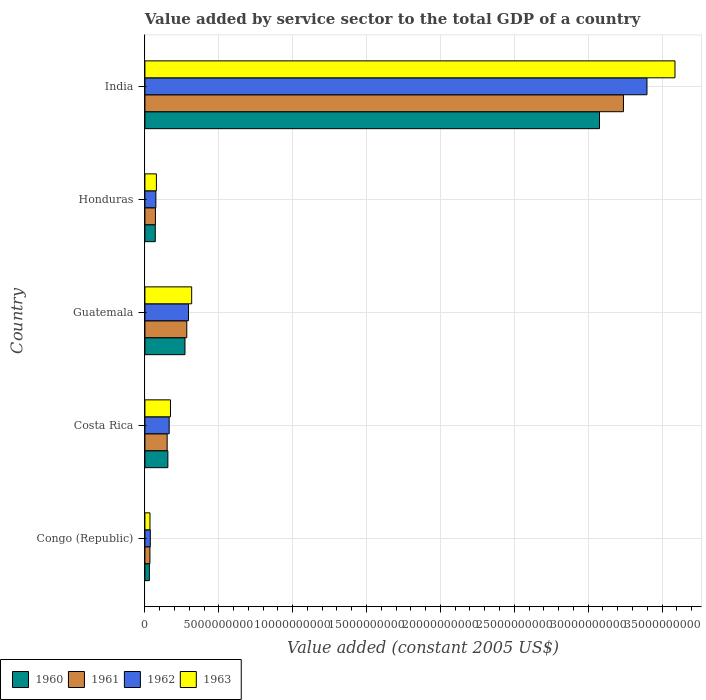Are the number of bars per tick equal to the number of legend labels?
Provide a short and direct response. Yes. How many bars are there on the 5th tick from the top?
Your answer should be compact. 4. How many bars are there on the 5th tick from the bottom?
Keep it short and to the point. 4. What is the label of the 3rd group of bars from the top?
Make the answer very short. Guatemala. What is the value added by service sector in 1960 in Guatemala?
Offer a very short reply. 2.71e+09. Across all countries, what is the maximum value added by service sector in 1962?
Make the answer very short. 3.40e+1. Across all countries, what is the minimum value added by service sector in 1961?
Your answer should be very brief. 3.39e+08. In which country was the value added by service sector in 1962 maximum?
Your response must be concise. India. In which country was the value added by service sector in 1962 minimum?
Your answer should be compact. Congo (Republic). What is the total value added by service sector in 1960 in the graph?
Provide a short and direct response. 3.60e+1. What is the difference between the value added by service sector in 1962 in Guatemala and that in India?
Provide a short and direct response. -3.10e+1. What is the difference between the value added by service sector in 1963 in India and the value added by service sector in 1961 in Congo (Republic)?
Provide a short and direct response. 3.55e+1. What is the average value added by service sector in 1963 per country?
Ensure brevity in your answer.  8.38e+09. What is the difference between the value added by service sector in 1961 and value added by service sector in 1960 in India?
Your response must be concise. 1.62e+09. In how many countries, is the value added by service sector in 1963 greater than 12000000000 US$?
Your response must be concise. 1. What is the ratio of the value added by service sector in 1963 in Congo (Republic) to that in Guatemala?
Offer a terse response. 0.11. Is the difference between the value added by service sector in 1961 in Costa Rica and India greater than the difference between the value added by service sector in 1960 in Costa Rica and India?
Your answer should be very brief. No. What is the difference between the highest and the second highest value added by service sector in 1963?
Provide a short and direct response. 3.27e+1. What is the difference between the highest and the lowest value added by service sector in 1962?
Provide a succinct answer. 3.36e+1. Is the sum of the value added by service sector in 1962 in Costa Rica and Guatemala greater than the maximum value added by service sector in 1963 across all countries?
Keep it short and to the point. No. What does the 2nd bar from the top in Costa Rica represents?
Keep it short and to the point. 1962. Is it the case that in every country, the sum of the value added by service sector in 1963 and value added by service sector in 1961 is greater than the value added by service sector in 1960?
Offer a very short reply. Yes. How many bars are there?
Offer a terse response. 20. Are all the bars in the graph horizontal?
Your answer should be very brief. Yes. Are the values on the major ticks of X-axis written in scientific E-notation?
Give a very brief answer. No. Where does the legend appear in the graph?
Your answer should be compact. Bottom left. How many legend labels are there?
Your response must be concise. 4. How are the legend labels stacked?
Make the answer very short. Horizontal. What is the title of the graph?
Give a very brief answer. Value added by service sector to the total GDP of a country. Does "1988" appear as one of the legend labels in the graph?
Your response must be concise. No. What is the label or title of the X-axis?
Keep it short and to the point. Value added (constant 2005 US$). What is the label or title of the Y-axis?
Your answer should be compact. Country. What is the Value added (constant 2005 US$) of 1960 in Congo (Republic)?
Offer a terse response. 3.02e+08. What is the Value added (constant 2005 US$) of 1961 in Congo (Republic)?
Offer a terse response. 3.39e+08. What is the Value added (constant 2005 US$) of 1962 in Congo (Republic)?
Give a very brief answer. 3.64e+08. What is the Value added (constant 2005 US$) of 1963 in Congo (Republic)?
Provide a short and direct response. 3.42e+08. What is the Value added (constant 2005 US$) of 1960 in Costa Rica?
Make the answer very short. 1.55e+09. What is the Value added (constant 2005 US$) of 1961 in Costa Rica?
Offer a terse response. 1.51e+09. What is the Value added (constant 2005 US$) in 1962 in Costa Rica?
Your response must be concise. 1.64e+09. What is the Value added (constant 2005 US$) of 1963 in Costa Rica?
Keep it short and to the point. 1.73e+09. What is the Value added (constant 2005 US$) of 1960 in Guatemala?
Provide a short and direct response. 2.71e+09. What is the Value added (constant 2005 US$) of 1961 in Guatemala?
Keep it short and to the point. 2.83e+09. What is the Value added (constant 2005 US$) of 1962 in Guatemala?
Ensure brevity in your answer.  2.95e+09. What is the Value added (constant 2005 US$) of 1963 in Guatemala?
Your answer should be very brief. 3.16e+09. What is the Value added (constant 2005 US$) in 1960 in Honduras?
Give a very brief answer. 7.01e+08. What is the Value added (constant 2005 US$) in 1961 in Honduras?
Your answer should be compact. 7.12e+08. What is the Value added (constant 2005 US$) of 1962 in Honduras?
Provide a succinct answer. 7.41e+08. What is the Value added (constant 2005 US$) of 1963 in Honduras?
Your answer should be very brief. 7.78e+08. What is the Value added (constant 2005 US$) of 1960 in India?
Your answer should be very brief. 3.08e+1. What is the Value added (constant 2005 US$) of 1961 in India?
Keep it short and to the point. 3.24e+1. What is the Value added (constant 2005 US$) of 1962 in India?
Your response must be concise. 3.40e+1. What is the Value added (constant 2005 US$) of 1963 in India?
Make the answer very short. 3.59e+1. Across all countries, what is the maximum Value added (constant 2005 US$) in 1960?
Your response must be concise. 3.08e+1. Across all countries, what is the maximum Value added (constant 2005 US$) in 1961?
Make the answer very short. 3.24e+1. Across all countries, what is the maximum Value added (constant 2005 US$) of 1962?
Offer a very short reply. 3.40e+1. Across all countries, what is the maximum Value added (constant 2005 US$) in 1963?
Ensure brevity in your answer.  3.59e+1. Across all countries, what is the minimum Value added (constant 2005 US$) of 1960?
Provide a succinct answer. 3.02e+08. Across all countries, what is the minimum Value added (constant 2005 US$) of 1961?
Offer a terse response. 3.39e+08. Across all countries, what is the minimum Value added (constant 2005 US$) in 1962?
Your response must be concise. 3.64e+08. Across all countries, what is the minimum Value added (constant 2005 US$) in 1963?
Provide a short and direct response. 3.42e+08. What is the total Value added (constant 2005 US$) in 1960 in the graph?
Give a very brief answer. 3.60e+1. What is the total Value added (constant 2005 US$) of 1961 in the graph?
Offer a very short reply. 3.78e+1. What is the total Value added (constant 2005 US$) in 1962 in the graph?
Offer a terse response. 3.97e+1. What is the total Value added (constant 2005 US$) in 1963 in the graph?
Give a very brief answer. 4.19e+1. What is the difference between the Value added (constant 2005 US$) in 1960 in Congo (Republic) and that in Costa Rica?
Give a very brief answer. -1.25e+09. What is the difference between the Value added (constant 2005 US$) of 1961 in Congo (Republic) and that in Costa Rica?
Ensure brevity in your answer.  -1.17e+09. What is the difference between the Value added (constant 2005 US$) of 1962 in Congo (Republic) and that in Costa Rica?
Provide a short and direct response. -1.28e+09. What is the difference between the Value added (constant 2005 US$) in 1963 in Congo (Republic) and that in Costa Rica?
Provide a short and direct response. -1.39e+09. What is the difference between the Value added (constant 2005 US$) of 1960 in Congo (Republic) and that in Guatemala?
Your answer should be very brief. -2.41e+09. What is the difference between the Value added (constant 2005 US$) in 1961 in Congo (Republic) and that in Guatemala?
Offer a terse response. -2.49e+09. What is the difference between the Value added (constant 2005 US$) of 1962 in Congo (Republic) and that in Guatemala?
Provide a succinct answer. -2.58e+09. What is the difference between the Value added (constant 2005 US$) in 1963 in Congo (Republic) and that in Guatemala?
Your answer should be very brief. -2.82e+09. What is the difference between the Value added (constant 2005 US$) of 1960 in Congo (Republic) and that in Honduras?
Offer a terse response. -4.00e+08. What is the difference between the Value added (constant 2005 US$) of 1961 in Congo (Republic) and that in Honduras?
Offer a terse response. -3.73e+08. What is the difference between the Value added (constant 2005 US$) of 1962 in Congo (Republic) and that in Honduras?
Offer a terse response. -3.77e+08. What is the difference between the Value added (constant 2005 US$) of 1963 in Congo (Republic) and that in Honduras?
Your answer should be very brief. -4.36e+08. What is the difference between the Value added (constant 2005 US$) in 1960 in Congo (Republic) and that in India?
Provide a succinct answer. -3.05e+1. What is the difference between the Value added (constant 2005 US$) of 1961 in Congo (Republic) and that in India?
Offer a terse response. -3.21e+1. What is the difference between the Value added (constant 2005 US$) of 1962 in Congo (Republic) and that in India?
Provide a succinct answer. -3.36e+1. What is the difference between the Value added (constant 2005 US$) of 1963 in Congo (Republic) and that in India?
Keep it short and to the point. -3.55e+1. What is the difference between the Value added (constant 2005 US$) of 1960 in Costa Rica and that in Guatemala?
Your answer should be compact. -1.16e+09. What is the difference between the Value added (constant 2005 US$) of 1961 in Costa Rica and that in Guatemala?
Offer a terse response. -1.33e+09. What is the difference between the Value added (constant 2005 US$) in 1962 in Costa Rica and that in Guatemala?
Give a very brief answer. -1.31e+09. What is the difference between the Value added (constant 2005 US$) in 1963 in Costa Rica and that in Guatemala?
Offer a terse response. -1.43e+09. What is the difference between the Value added (constant 2005 US$) of 1960 in Costa Rica and that in Honduras?
Offer a terse response. 8.51e+08. What is the difference between the Value added (constant 2005 US$) in 1961 in Costa Rica and that in Honduras?
Provide a succinct answer. 7.94e+08. What is the difference between the Value added (constant 2005 US$) of 1962 in Costa Rica and that in Honduras?
Offer a terse response. 9.01e+08. What is the difference between the Value added (constant 2005 US$) in 1963 in Costa Rica and that in Honduras?
Offer a very short reply. 9.53e+08. What is the difference between the Value added (constant 2005 US$) in 1960 in Costa Rica and that in India?
Provide a short and direct response. -2.92e+1. What is the difference between the Value added (constant 2005 US$) of 1961 in Costa Rica and that in India?
Provide a short and direct response. -3.09e+1. What is the difference between the Value added (constant 2005 US$) in 1962 in Costa Rica and that in India?
Give a very brief answer. -3.23e+1. What is the difference between the Value added (constant 2005 US$) in 1963 in Costa Rica and that in India?
Provide a short and direct response. -3.41e+1. What is the difference between the Value added (constant 2005 US$) in 1960 in Guatemala and that in Honduras?
Your answer should be very brief. 2.01e+09. What is the difference between the Value added (constant 2005 US$) of 1961 in Guatemala and that in Honduras?
Your answer should be compact. 2.12e+09. What is the difference between the Value added (constant 2005 US$) of 1962 in Guatemala and that in Honduras?
Keep it short and to the point. 2.21e+09. What is the difference between the Value added (constant 2005 US$) in 1963 in Guatemala and that in Honduras?
Keep it short and to the point. 2.39e+09. What is the difference between the Value added (constant 2005 US$) of 1960 in Guatemala and that in India?
Provide a succinct answer. -2.81e+1. What is the difference between the Value added (constant 2005 US$) of 1961 in Guatemala and that in India?
Keep it short and to the point. -2.96e+1. What is the difference between the Value added (constant 2005 US$) in 1962 in Guatemala and that in India?
Offer a terse response. -3.10e+1. What is the difference between the Value added (constant 2005 US$) of 1963 in Guatemala and that in India?
Your response must be concise. -3.27e+1. What is the difference between the Value added (constant 2005 US$) of 1960 in Honduras and that in India?
Ensure brevity in your answer.  -3.01e+1. What is the difference between the Value added (constant 2005 US$) of 1961 in Honduras and that in India?
Give a very brief answer. -3.17e+1. What is the difference between the Value added (constant 2005 US$) of 1962 in Honduras and that in India?
Ensure brevity in your answer.  -3.32e+1. What is the difference between the Value added (constant 2005 US$) of 1963 in Honduras and that in India?
Your answer should be very brief. -3.51e+1. What is the difference between the Value added (constant 2005 US$) in 1960 in Congo (Republic) and the Value added (constant 2005 US$) in 1961 in Costa Rica?
Provide a short and direct response. -1.20e+09. What is the difference between the Value added (constant 2005 US$) of 1960 in Congo (Republic) and the Value added (constant 2005 US$) of 1962 in Costa Rica?
Offer a terse response. -1.34e+09. What is the difference between the Value added (constant 2005 US$) of 1960 in Congo (Republic) and the Value added (constant 2005 US$) of 1963 in Costa Rica?
Your response must be concise. -1.43e+09. What is the difference between the Value added (constant 2005 US$) in 1961 in Congo (Republic) and the Value added (constant 2005 US$) in 1962 in Costa Rica?
Provide a succinct answer. -1.30e+09. What is the difference between the Value added (constant 2005 US$) of 1961 in Congo (Republic) and the Value added (constant 2005 US$) of 1963 in Costa Rica?
Offer a terse response. -1.39e+09. What is the difference between the Value added (constant 2005 US$) in 1962 in Congo (Republic) and the Value added (constant 2005 US$) in 1963 in Costa Rica?
Provide a short and direct response. -1.37e+09. What is the difference between the Value added (constant 2005 US$) in 1960 in Congo (Republic) and the Value added (constant 2005 US$) in 1961 in Guatemala?
Your answer should be compact. -2.53e+09. What is the difference between the Value added (constant 2005 US$) in 1960 in Congo (Republic) and the Value added (constant 2005 US$) in 1962 in Guatemala?
Make the answer very short. -2.65e+09. What is the difference between the Value added (constant 2005 US$) of 1960 in Congo (Republic) and the Value added (constant 2005 US$) of 1963 in Guatemala?
Your response must be concise. -2.86e+09. What is the difference between the Value added (constant 2005 US$) of 1961 in Congo (Republic) and the Value added (constant 2005 US$) of 1962 in Guatemala?
Your answer should be compact. -2.61e+09. What is the difference between the Value added (constant 2005 US$) of 1961 in Congo (Republic) and the Value added (constant 2005 US$) of 1963 in Guatemala?
Your answer should be compact. -2.83e+09. What is the difference between the Value added (constant 2005 US$) of 1962 in Congo (Republic) and the Value added (constant 2005 US$) of 1963 in Guatemala?
Make the answer very short. -2.80e+09. What is the difference between the Value added (constant 2005 US$) in 1960 in Congo (Republic) and the Value added (constant 2005 US$) in 1961 in Honduras?
Give a very brief answer. -4.10e+08. What is the difference between the Value added (constant 2005 US$) in 1960 in Congo (Republic) and the Value added (constant 2005 US$) in 1962 in Honduras?
Your answer should be compact. -4.39e+08. What is the difference between the Value added (constant 2005 US$) in 1960 in Congo (Republic) and the Value added (constant 2005 US$) in 1963 in Honduras?
Ensure brevity in your answer.  -4.76e+08. What is the difference between the Value added (constant 2005 US$) of 1961 in Congo (Republic) and the Value added (constant 2005 US$) of 1962 in Honduras?
Give a very brief answer. -4.02e+08. What is the difference between the Value added (constant 2005 US$) of 1961 in Congo (Republic) and the Value added (constant 2005 US$) of 1963 in Honduras?
Ensure brevity in your answer.  -4.39e+08. What is the difference between the Value added (constant 2005 US$) of 1962 in Congo (Republic) and the Value added (constant 2005 US$) of 1963 in Honduras?
Your answer should be very brief. -4.14e+08. What is the difference between the Value added (constant 2005 US$) in 1960 in Congo (Republic) and the Value added (constant 2005 US$) in 1961 in India?
Your answer should be very brief. -3.21e+1. What is the difference between the Value added (constant 2005 US$) of 1960 in Congo (Republic) and the Value added (constant 2005 US$) of 1962 in India?
Offer a very short reply. -3.37e+1. What is the difference between the Value added (constant 2005 US$) in 1960 in Congo (Republic) and the Value added (constant 2005 US$) in 1963 in India?
Offer a very short reply. -3.56e+1. What is the difference between the Value added (constant 2005 US$) in 1961 in Congo (Republic) and the Value added (constant 2005 US$) in 1962 in India?
Your response must be concise. -3.36e+1. What is the difference between the Value added (constant 2005 US$) of 1961 in Congo (Republic) and the Value added (constant 2005 US$) of 1963 in India?
Keep it short and to the point. -3.55e+1. What is the difference between the Value added (constant 2005 US$) of 1962 in Congo (Republic) and the Value added (constant 2005 US$) of 1963 in India?
Offer a terse response. -3.55e+1. What is the difference between the Value added (constant 2005 US$) in 1960 in Costa Rica and the Value added (constant 2005 US$) in 1961 in Guatemala?
Your answer should be very brief. -1.28e+09. What is the difference between the Value added (constant 2005 US$) of 1960 in Costa Rica and the Value added (constant 2005 US$) of 1962 in Guatemala?
Give a very brief answer. -1.39e+09. What is the difference between the Value added (constant 2005 US$) in 1960 in Costa Rica and the Value added (constant 2005 US$) in 1963 in Guatemala?
Keep it short and to the point. -1.61e+09. What is the difference between the Value added (constant 2005 US$) in 1961 in Costa Rica and the Value added (constant 2005 US$) in 1962 in Guatemala?
Offer a very short reply. -1.44e+09. What is the difference between the Value added (constant 2005 US$) of 1961 in Costa Rica and the Value added (constant 2005 US$) of 1963 in Guatemala?
Your response must be concise. -1.66e+09. What is the difference between the Value added (constant 2005 US$) of 1962 in Costa Rica and the Value added (constant 2005 US$) of 1963 in Guatemala?
Your answer should be compact. -1.52e+09. What is the difference between the Value added (constant 2005 US$) of 1960 in Costa Rica and the Value added (constant 2005 US$) of 1961 in Honduras?
Provide a short and direct response. 8.41e+08. What is the difference between the Value added (constant 2005 US$) of 1960 in Costa Rica and the Value added (constant 2005 US$) of 1962 in Honduras?
Your answer should be compact. 8.12e+08. What is the difference between the Value added (constant 2005 US$) in 1960 in Costa Rica and the Value added (constant 2005 US$) in 1963 in Honduras?
Make the answer very short. 7.75e+08. What is the difference between the Value added (constant 2005 US$) in 1961 in Costa Rica and the Value added (constant 2005 US$) in 1962 in Honduras?
Your answer should be very brief. 7.65e+08. What is the difference between the Value added (constant 2005 US$) of 1961 in Costa Rica and the Value added (constant 2005 US$) of 1963 in Honduras?
Make the answer very short. 7.28e+08. What is the difference between the Value added (constant 2005 US$) in 1962 in Costa Rica and the Value added (constant 2005 US$) in 1963 in Honduras?
Keep it short and to the point. 8.63e+08. What is the difference between the Value added (constant 2005 US$) in 1960 in Costa Rica and the Value added (constant 2005 US$) in 1961 in India?
Make the answer very short. -3.08e+1. What is the difference between the Value added (constant 2005 US$) in 1960 in Costa Rica and the Value added (constant 2005 US$) in 1962 in India?
Ensure brevity in your answer.  -3.24e+1. What is the difference between the Value added (constant 2005 US$) of 1960 in Costa Rica and the Value added (constant 2005 US$) of 1963 in India?
Offer a very short reply. -3.43e+1. What is the difference between the Value added (constant 2005 US$) of 1961 in Costa Rica and the Value added (constant 2005 US$) of 1962 in India?
Your answer should be compact. -3.25e+1. What is the difference between the Value added (constant 2005 US$) in 1961 in Costa Rica and the Value added (constant 2005 US$) in 1963 in India?
Your answer should be compact. -3.44e+1. What is the difference between the Value added (constant 2005 US$) of 1962 in Costa Rica and the Value added (constant 2005 US$) of 1963 in India?
Give a very brief answer. -3.42e+1. What is the difference between the Value added (constant 2005 US$) of 1960 in Guatemala and the Value added (constant 2005 US$) of 1961 in Honduras?
Your answer should be compact. 2.00e+09. What is the difference between the Value added (constant 2005 US$) of 1960 in Guatemala and the Value added (constant 2005 US$) of 1962 in Honduras?
Offer a very short reply. 1.97e+09. What is the difference between the Value added (constant 2005 US$) of 1960 in Guatemala and the Value added (constant 2005 US$) of 1963 in Honduras?
Your answer should be very brief. 1.93e+09. What is the difference between the Value added (constant 2005 US$) in 1961 in Guatemala and the Value added (constant 2005 US$) in 1962 in Honduras?
Your answer should be very brief. 2.09e+09. What is the difference between the Value added (constant 2005 US$) in 1961 in Guatemala and the Value added (constant 2005 US$) in 1963 in Honduras?
Offer a very short reply. 2.06e+09. What is the difference between the Value added (constant 2005 US$) in 1962 in Guatemala and the Value added (constant 2005 US$) in 1963 in Honduras?
Provide a short and direct response. 2.17e+09. What is the difference between the Value added (constant 2005 US$) of 1960 in Guatemala and the Value added (constant 2005 US$) of 1961 in India?
Make the answer very short. -2.97e+1. What is the difference between the Value added (constant 2005 US$) of 1960 in Guatemala and the Value added (constant 2005 US$) of 1962 in India?
Keep it short and to the point. -3.13e+1. What is the difference between the Value added (constant 2005 US$) in 1960 in Guatemala and the Value added (constant 2005 US$) in 1963 in India?
Provide a succinct answer. -3.32e+1. What is the difference between the Value added (constant 2005 US$) of 1961 in Guatemala and the Value added (constant 2005 US$) of 1962 in India?
Your answer should be compact. -3.11e+1. What is the difference between the Value added (constant 2005 US$) in 1961 in Guatemala and the Value added (constant 2005 US$) in 1963 in India?
Give a very brief answer. -3.30e+1. What is the difference between the Value added (constant 2005 US$) of 1962 in Guatemala and the Value added (constant 2005 US$) of 1963 in India?
Your response must be concise. -3.29e+1. What is the difference between the Value added (constant 2005 US$) in 1960 in Honduras and the Value added (constant 2005 US$) in 1961 in India?
Your answer should be very brief. -3.17e+1. What is the difference between the Value added (constant 2005 US$) of 1960 in Honduras and the Value added (constant 2005 US$) of 1962 in India?
Offer a terse response. -3.33e+1. What is the difference between the Value added (constant 2005 US$) in 1960 in Honduras and the Value added (constant 2005 US$) in 1963 in India?
Offer a very short reply. -3.52e+1. What is the difference between the Value added (constant 2005 US$) of 1961 in Honduras and the Value added (constant 2005 US$) of 1962 in India?
Provide a succinct answer. -3.33e+1. What is the difference between the Value added (constant 2005 US$) of 1961 in Honduras and the Value added (constant 2005 US$) of 1963 in India?
Your answer should be compact. -3.52e+1. What is the difference between the Value added (constant 2005 US$) in 1962 in Honduras and the Value added (constant 2005 US$) in 1963 in India?
Keep it short and to the point. -3.51e+1. What is the average Value added (constant 2005 US$) in 1960 per country?
Provide a short and direct response. 7.21e+09. What is the average Value added (constant 2005 US$) of 1961 per country?
Offer a very short reply. 7.56e+09. What is the average Value added (constant 2005 US$) of 1962 per country?
Your answer should be very brief. 7.93e+09. What is the average Value added (constant 2005 US$) of 1963 per country?
Provide a short and direct response. 8.38e+09. What is the difference between the Value added (constant 2005 US$) in 1960 and Value added (constant 2005 US$) in 1961 in Congo (Republic)?
Provide a short and direct response. -3.74e+07. What is the difference between the Value added (constant 2005 US$) in 1960 and Value added (constant 2005 US$) in 1962 in Congo (Republic)?
Ensure brevity in your answer.  -6.23e+07. What is the difference between the Value added (constant 2005 US$) in 1960 and Value added (constant 2005 US$) in 1963 in Congo (Republic)?
Provide a short and direct response. -4.05e+07. What is the difference between the Value added (constant 2005 US$) of 1961 and Value added (constant 2005 US$) of 1962 in Congo (Republic)?
Give a very brief answer. -2.49e+07. What is the difference between the Value added (constant 2005 US$) in 1961 and Value added (constant 2005 US$) in 1963 in Congo (Republic)?
Offer a very short reply. -3.09e+06. What is the difference between the Value added (constant 2005 US$) of 1962 and Value added (constant 2005 US$) of 1963 in Congo (Republic)?
Offer a terse response. 2.18e+07. What is the difference between the Value added (constant 2005 US$) of 1960 and Value added (constant 2005 US$) of 1961 in Costa Rica?
Give a very brief answer. 4.72e+07. What is the difference between the Value added (constant 2005 US$) in 1960 and Value added (constant 2005 US$) in 1962 in Costa Rica?
Give a very brief answer. -8.87e+07. What is the difference between the Value added (constant 2005 US$) in 1960 and Value added (constant 2005 US$) in 1963 in Costa Rica?
Provide a short and direct response. -1.78e+08. What is the difference between the Value added (constant 2005 US$) of 1961 and Value added (constant 2005 US$) of 1962 in Costa Rica?
Your response must be concise. -1.36e+08. What is the difference between the Value added (constant 2005 US$) in 1961 and Value added (constant 2005 US$) in 1963 in Costa Rica?
Provide a succinct answer. -2.25e+08. What is the difference between the Value added (constant 2005 US$) in 1962 and Value added (constant 2005 US$) in 1963 in Costa Rica?
Provide a succinct answer. -8.94e+07. What is the difference between the Value added (constant 2005 US$) of 1960 and Value added (constant 2005 US$) of 1961 in Guatemala?
Ensure brevity in your answer.  -1.22e+08. What is the difference between the Value added (constant 2005 US$) of 1960 and Value added (constant 2005 US$) of 1962 in Guatemala?
Make the answer very short. -2.35e+08. What is the difference between the Value added (constant 2005 US$) in 1960 and Value added (constant 2005 US$) in 1963 in Guatemala?
Provide a short and direct response. -4.53e+08. What is the difference between the Value added (constant 2005 US$) in 1961 and Value added (constant 2005 US$) in 1962 in Guatemala?
Offer a very short reply. -1.14e+08. What is the difference between the Value added (constant 2005 US$) in 1961 and Value added (constant 2005 US$) in 1963 in Guatemala?
Your answer should be very brief. -3.31e+08. What is the difference between the Value added (constant 2005 US$) in 1962 and Value added (constant 2005 US$) in 1963 in Guatemala?
Ensure brevity in your answer.  -2.17e+08. What is the difference between the Value added (constant 2005 US$) of 1960 and Value added (constant 2005 US$) of 1961 in Honduras?
Provide a succinct answer. -1.04e+07. What is the difference between the Value added (constant 2005 US$) in 1960 and Value added (constant 2005 US$) in 1962 in Honduras?
Provide a succinct answer. -3.93e+07. What is the difference between the Value added (constant 2005 US$) of 1960 and Value added (constant 2005 US$) of 1963 in Honduras?
Offer a very short reply. -7.65e+07. What is the difference between the Value added (constant 2005 US$) in 1961 and Value added (constant 2005 US$) in 1962 in Honduras?
Your answer should be compact. -2.89e+07. What is the difference between the Value added (constant 2005 US$) in 1961 and Value added (constant 2005 US$) in 1963 in Honduras?
Give a very brief answer. -6.62e+07. What is the difference between the Value added (constant 2005 US$) in 1962 and Value added (constant 2005 US$) in 1963 in Honduras?
Offer a very short reply. -3.72e+07. What is the difference between the Value added (constant 2005 US$) of 1960 and Value added (constant 2005 US$) of 1961 in India?
Give a very brief answer. -1.62e+09. What is the difference between the Value added (constant 2005 US$) of 1960 and Value added (constant 2005 US$) of 1962 in India?
Your answer should be very brief. -3.21e+09. What is the difference between the Value added (constant 2005 US$) of 1960 and Value added (constant 2005 US$) of 1963 in India?
Your answer should be compact. -5.11e+09. What is the difference between the Value added (constant 2005 US$) of 1961 and Value added (constant 2005 US$) of 1962 in India?
Offer a very short reply. -1.59e+09. What is the difference between the Value added (constant 2005 US$) of 1961 and Value added (constant 2005 US$) of 1963 in India?
Make the answer very short. -3.49e+09. What is the difference between the Value added (constant 2005 US$) of 1962 and Value added (constant 2005 US$) of 1963 in India?
Your response must be concise. -1.90e+09. What is the ratio of the Value added (constant 2005 US$) in 1960 in Congo (Republic) to that in Costa Rica?
Offer a very short reply. 0.19. What is the ratio of the Value added (constant 2005 US$) in 1961 in Congo (Republic) to that in Costa Rica?
Your answer should be compact. 0.23. What is the ratio of the Value added (constant 2005 US$) of 1962 in Congo (Republic) to that in Costa Rica?
Your answer should be compact. 0.22. What is the ratio of the Value added (constant 2005 US$) of 1963 in Congo (Republic) to that in Costa Rica?
Keep it short and to the point. 0.2. What is the ratio of the Value added (constant 2005 US$) of 1960 in Congo (Republic) to that in Guatemala?
Offer a terse response. 0.11. What is the ratio of the Value added (constant 2005 US$) in 1961 in Congo (Republic) to that in Guatemala?
Offer a terse response. 0.12. What is the ratio of the Value added (constant 2005 US$) in 1962 in Congo (Republic) to that in Guatemala?
Your response must be concise. 0.12. What is the ratio of the Value added (constant 2005 US$) of 1963 in Congo (Republic) to that in Guatemala?
Offer a very short reply. 0.11. What is the ratio of the Value added (constant 2005 US$) of 1960 in Congo (Republic) to that in Honduras?
Offer a very short reply. 0.43. What is the ratio of the Value added (constant 2005 US$) of 1961 in Congo (Republic) to that in Honduras?
Provide a short and direct response. 0.48. What is the ratio of the Value added (constant 2005 US$) in 1962 in Congo (Republic) to that in Honduras?
Provide a succinct answer. 0.49. What is the ratio of the Value added (constant 2005 US$) in 1963 in Congo (Republic) to that in Honduras?
Offer a very short reply. 0.44. What is the ratio of the Value added (constant 2005 US$) of 1960 in Congo (Republic) to that in India?
Your answer should be compact. 0.01. What is the ratio of the Value added (constant 2005 US$) in 1961 in Congo (Republic) to that in India?
Keep it short and to the point. 0.01. What is the ratio of the Value added (constant 2005 US$) in 1962 in Congo (Republic) to that in India?
Make the answer very short. 0.01. What is the ratio of the Value added (constant 2005 US$) in 1963 in Congo (Republic) to that in India?
Make the answer very short. 0.01. What is the ratio of the Value added (constant 2005 US$) in 1960 in Costa Rica to that in Guatemala?
Your response must be concise. 0.57. What is the ratio of the Value added (constant 2005 US$) of 1961 in Costa Rica to that in Guatemala?
Provide a short and direct response. 0.53. What is the ratio of the Value added (constant 2005 US$) in 1962 in Costa Rica to that in Guatemala?
Ensure brevity in your answer.  0.56. What is the ratio of the Value added (constant 2005 US$) in 1963 in Costa Rica to that in Guatemala?
Provide a short and direct response. 0.55. What is the ratio of the Value added (constant 2005 US$) of 1960 in Costa Rica to that in Honduras?
Offer a terse response. 2.21. What is the ratio of the Value added (constant 2005 US$) of 1961 in Costa Rica to that in Honduras?
Give a very brief answer. 2.12. What is the ratio of the Value added (constant 2005 US$) of 1962 in Costa Rica to that in Honduras?
Offer a very short reply. 2.22. What is the ratio of the Value added (constant 2005 US$) in 1963 in Costa Rica to that in Honduras?
Your answer should be compact. 2.23. What is the ratio of the Value added (constant 2005 US$) of 1960 in Costa Rica to that in India?
Your answer should be very brief. 0.05. What is the ratio of the Value added (constant 2005 US$) in 1961 in Costa Rica to that in India?
Provide a short and direct response. 0.05. What is the ratio of the Value added (constant 2005 US$) of 1962 in Costa Rica to that in India?
Keep it short and to the point. 0.05. What is the ratio of the Value added (constant 2005 US$) in 1963 in Costa Rica to that in India?
Your answer should be compact. 0.05. What is the ratio of the Value added (constant 2005 US$) of 1960 in Guatemala to that in Honduras?
Offer a very short reply. 3.87. What is the ratio of the Value added (constant 2005 US$) in 1961 in Guatemala to that in Honduras?
Your response must be concise. 3.98. What is the ratio of the Value added (constant 2005 US$) in 1962 in Guatemala to that in Honduras?
Offer a very short reply. 3.98. What is the ratio of the Value added (constant 2005 US$) in 1963 in Guatemala to that in Honduras?
Make the answer very short. 4.07. What is the ratio of the Value added (constant 2005 US$) of 1960 in Guatemala to that in India?
Your answer should be compact. 0.09. What is the ratio of the Value added (constant 2005 US$) in 1961 in Guatemala to that in India?
Your answer should be compact. 0.09. What is the ratio of the Value added (constant 2005 US$) of 1962 in Guatemala to that in India?
Keep it short and to the point. 0.09. What is the ratio of the Value added (constant 2005 US$) of 1963 in Guatemala to that in India?
Your response must be concise. 0.09. What is the ratio of the Value added (constant 2005 US$) of 1960 in Honduras to that in India?
Offer a terse response. 0.02. What is the ratio of the Value added (constant 2005 US$) in 1961 in Honduras to that in India?
Ensure brevity in your answer.  0.02. What is the ratio of the Value added (constant 2005 US$) of 1962 in Honduras to that in India?
Your answer should be compact. 0.02. What is the ratio of the Value added (constant 2005 US$) in 1963 in Honduras to that in India?
Your answer should be compact. 0.02. What is the difference between the highest and the second highest Value added (constant 2005 US$) of 1960?
Make the answer very short. 2.81e+1. What is the difference between the highest and the second highest Value added (constant 2005 US$) of 1961?
Your answer should be very brief. 2.96e+1. What is the difference between the highest and the second highest Value added (constant 2005 US$) of 1962?
Give a very brief answer. 3.10e+1. What is the difference between the highest and the second highest Value added (constant 2005 US$) in 1963?
Give a very brief answer. 3.27e+1. What is the difference between the highest and the lowest Value added (constant 2005 US$) in 1960?
Provide a short and direct response. 3.05e+1. What is the difference between the highest and the lowest Value added (constant 2005 US$) in 1961?
Give a very brief answer. 3.21e+1. What is the difference between the highest and the lowest Value added (constant 2005 US$) of 1962?
Your answer should be compact. 3.36e+1. What is the difference between the highest and the lowest Value added (constant 2005 US$) of 1963?
Provide a succinct answer. 3.55e+1. 